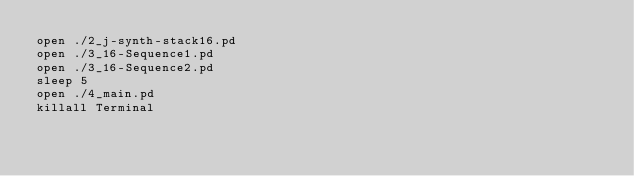Convert code to text. <code><loc_0><loc_0><loc_500><loc_500><_Bash_>open ./2_j-synth-stack16.pd
open ./3_16-Sequence1.pd
open ./3_16-Sequence2.pd
sleep 5
open ./4_main.pd
killall Terminal
</code> 